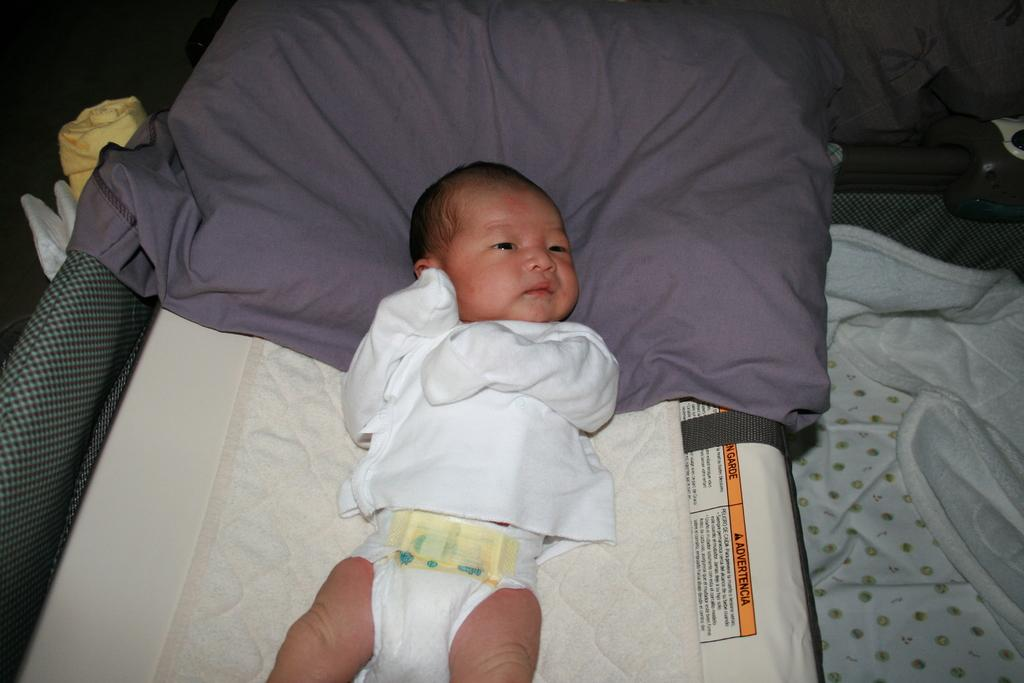What piece of furniture is present in the image? There is a bed in the image. What is the baby doing on the bed? The baby is sleeping on the bed. What is covering the baby on the bed? There are blankets on the bed. What type of drawer is being attacked by the baby in the image? There is no drawer present in the image, and the baby is sleeping, not attacking anything. 